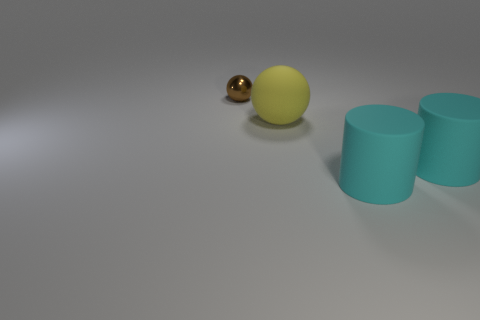Add 3 big gray cylinders. How many objects exist? 7 Subtract all big spheres. Subtract all large brown objects. How many objects are left? 3 Add 1 yellow things. How many yellow things are left? 2 Add 4 cyan rubber cylinders. How many cyan rubber cylinders exist? 6 Subtract 0 blue spheres. How many objects are left? 4 